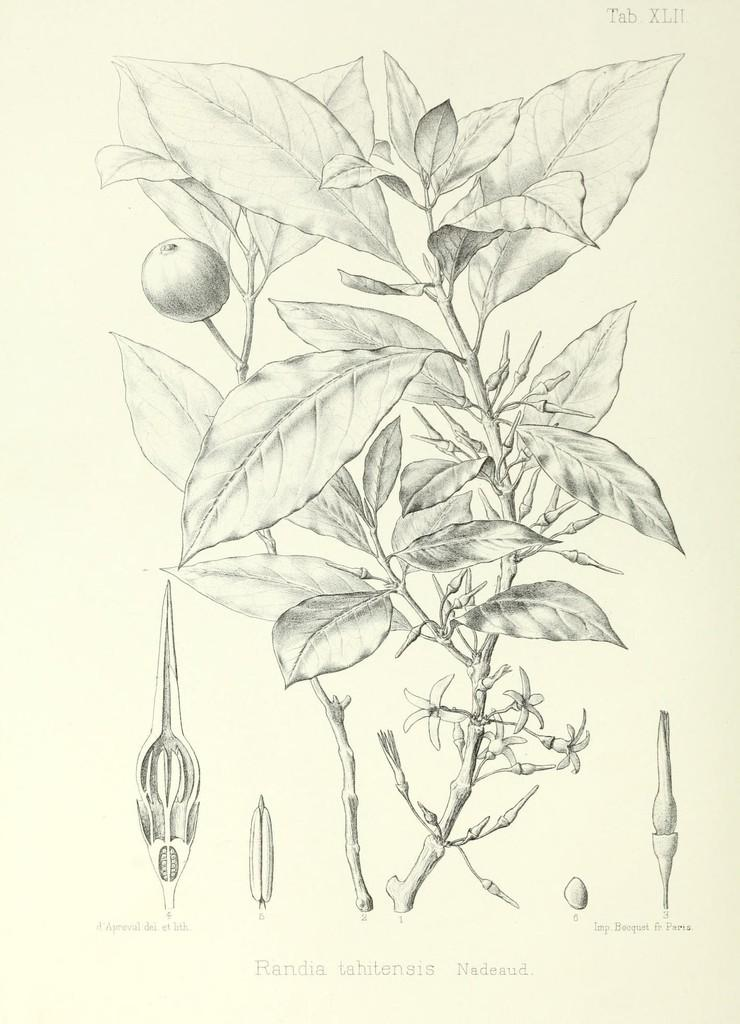What is the main subject in the center of the image? There is a plant in the center of the image. What can be seen on the right side of the image? There are parts of plants on the right side of the image. What can be seen on the left side of the image? There are parts of plants on the left side of the image. What else is present in the image besides the plants? There is text in the image. How does the plant feel pain in the image? Plants do not have the ability to feel pain, so this cannot be observed in the image. 